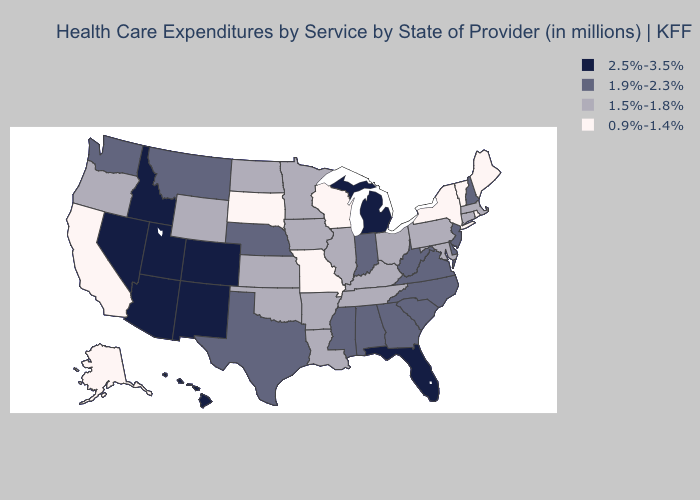What is the lowest value in the USA?
Answer briefly. 0.9%-1.4%. Name the states that have a value in the range 0.9%-1.4%?
Keep it brief. Alaska, California, Maine, Missouri, New York, Rhode Island, South Dakota, Vermont, Wisconsin. Among the states that border Michigan , does Wisconsin have the highest value?
Keep it brief. No. Which states have the lowest value in the USA?
Concise answer only. Alaska, California, Maine, Missouri, New York, Rhode Island, South Dakota, Vermont, Wisconsin. Does Arizona have the highest value in the West?
Be succinct. Yes. What is the value of Georgia?
Keep it brief. 1.9%-2.3%. Does the map have missing data?
Give a very brief answer. No. What is the value of Montana?
Be succinct. 1.9%-2.3%. Which states hav the highest value in the MidWest?
Quick response, please. Michigan. Name the states that have a value in the range 1.9%-2.3%?
Quick response, please. Alabama, Delaware, Georgia, Indiana, Mississippi, Montana, Nebraska, New Hampshire, New Jersey, North Carolina, South Carolina, Texas, Virginia, Washington, West Virginia. What is the lowest value in states that border Arizona?
Keep it brief. 0.9%-1.4%. What is the value of New Jersey?
Answer briefly. 1.9%-2.3%. What is the value of Georgia?
Keep it brief. 1.9%-2.3%. What is the value of Illinois?
Keep it brief. 1.5%-1.8%. What is the value of New York?
Be succinct. 0.9%-1.4%. 